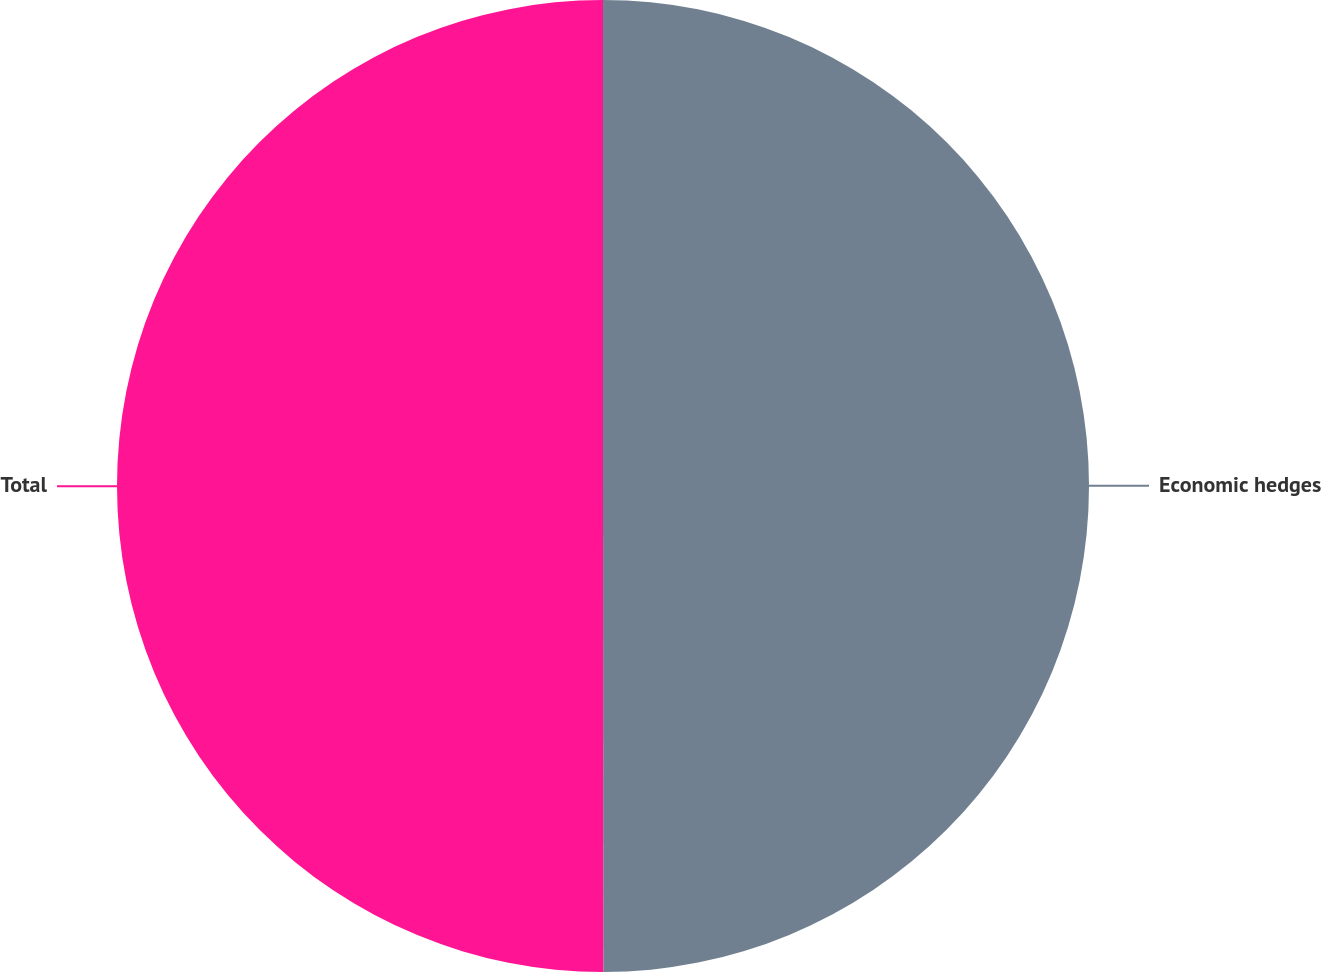<chart> <loc_0><loc_0><loc_500><loc_500><pie_chart><fcel>Economic hedges<fcel>Total<nl><fcel>49.99%<fcel>50.01%<nl></chart> 